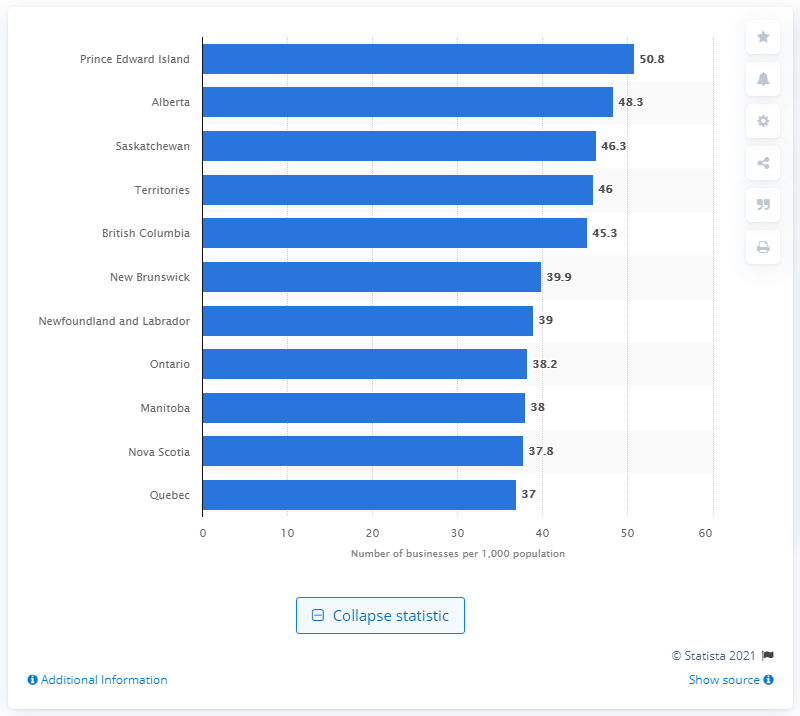Specify some key components in this picture. In December 2019, the business activity per 1,000 residents in Prince Edward Island was 50.8, indicating a steady level of economic activity in the province. 